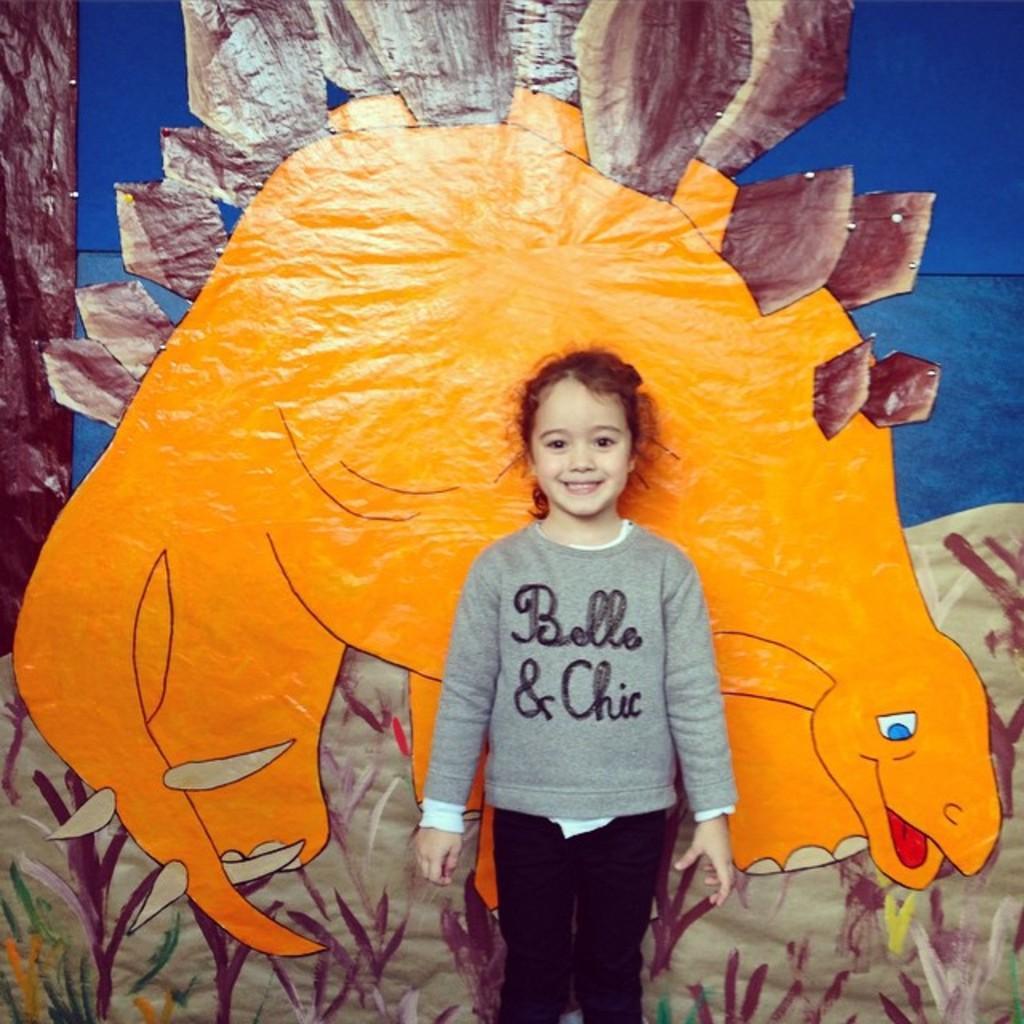Could you give a brief overview of what you see in this image? As we can see in the image there is a girl standing and drawing of an animal and plants. 